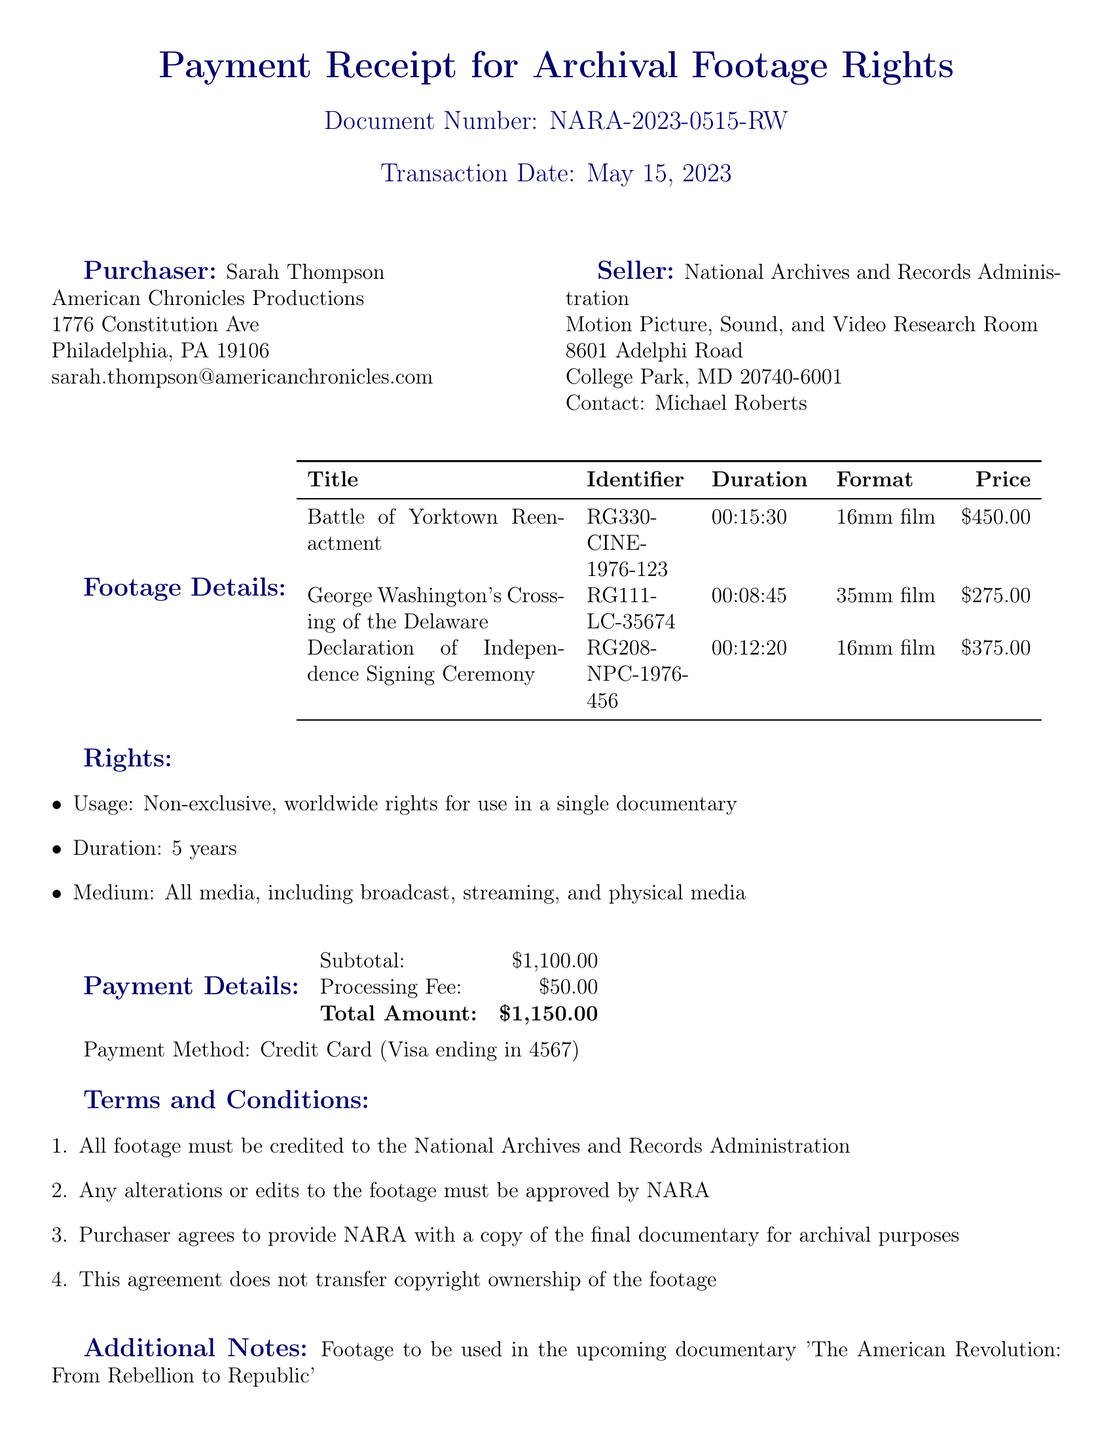what is the transaction date? The transaction date is explicitly stated in the document as May 15, 2023.
Answer: May 15, 2023 who is the purchaser? The purchaser's name is provided in the document as Sarah Thompson.
Answer: Sarah Thompson what is the total amount paid for the archival footage? The total amount paid is listed in the payment details section of the document as $1,150.00.
Answer: $1,150.00 how many years are the footage rights granted for? The duration for which the rights are granted is specified in the rights section of the document as 5 years.
Answer: 5 years what is the price of "George Washington's Crossing of the Delaware"? The price for "George Washington's Crossing of the Delaware" is presented in the footage details table as $275.00.
Answer: $275.00 which footage has a duration of 15 minutes and 30 seconds? The document provides the title "Battle of Yorktown Reenactment" for footage with a duration of 15 minutes and 30 seconds.
Answer: Battle of Yorktown Reenactment what is one term stated in the terms and conditions? The terms and conditions section specifies that "All footage must be credited to the National Archives and Records Administration."
Answer: All footage must be credited to the National Archives and Records Administration who signed the document as the seller? The seller's name is indicated in the signatures section of the document as Michael Roberts.
Answer: Michael Roberts in which documentary will the purchased footage be used? The additional notes section mentions that the footage will be used in "The American Revolution: From Rebellion to Republic."
Answer: The American Revolution: From Rebellion to Republic 